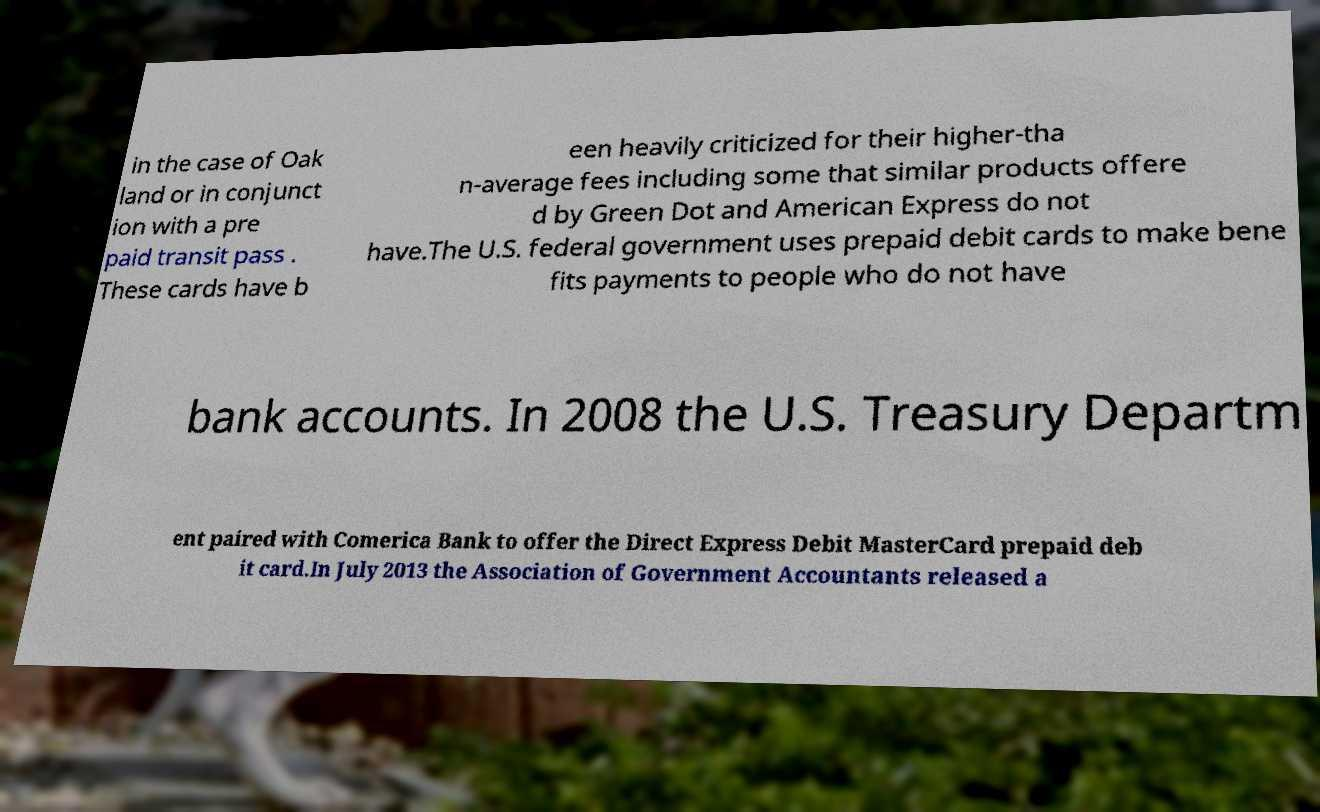I need the written content from this picture converted into text. Can you do that? in the case of Oak land or in conjunct ion with a pre paid transit pass . These cards have b een heavily criticized for their higher-tha n-average fees including some that similar products offere d by Green Dot and American Express do not have.The U.S. federal government uses prepaid debit cards to make bene fits payments to people who do not have bank accounts. In 2008 the U.S. Treasury Departm ent paired with Comerica Bank to offer the Direct Express Debit MasterCard prepaid deb it card.In July 2013 the Association of Government Accountants released a 